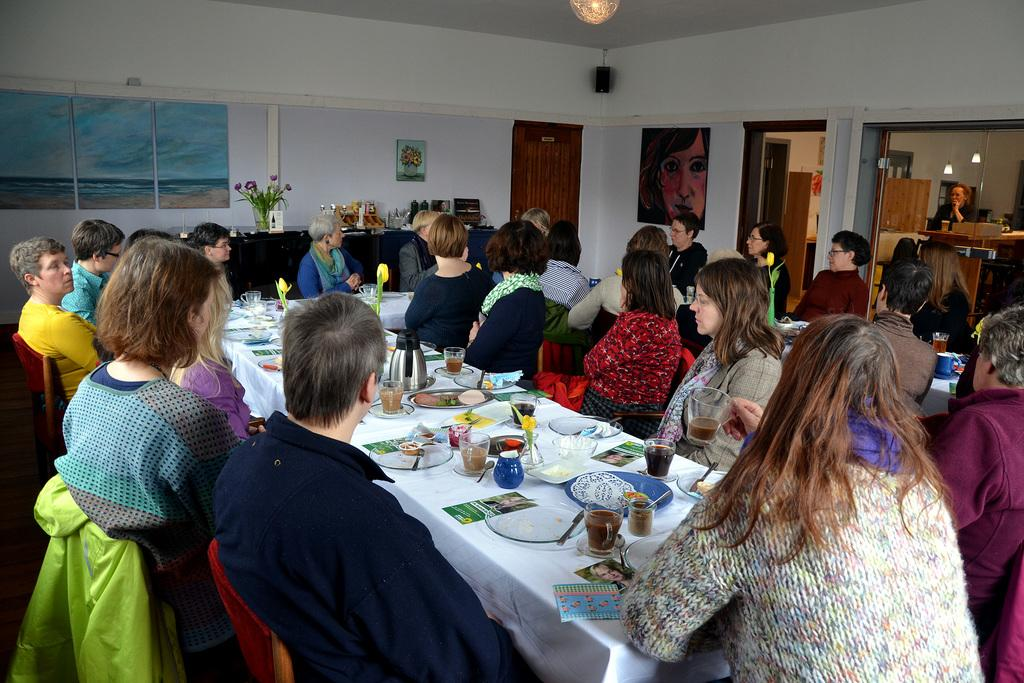What are the people in the image doing? There is a group of people sitting on chairs in the image. What is on the table in the image? There is a plate, a flask, a glass, a spoon, and a flower vase on the table in the image. How many items can be seen on the table? There are six items on the table: a plate, a flask, a glass, a spoon, and a flower vase. Can you tell me how many goats are present in the image? There are no goats present in the image. What type of coat is the growth wearing in the image? There is no growth or coat present in the image. 